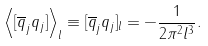<formula> <loc_0><loc_0><loc_500><loc_500>\left < [ \overline { q } _ { j } q _ { j } ] \right > _ { l } \equiv [ \overline { q } _ { j } q _ { j } ] _ { l } = - \frac { 1 } { 2 \pi ^ { 2 } l ^ { 3 } } .</formula> 